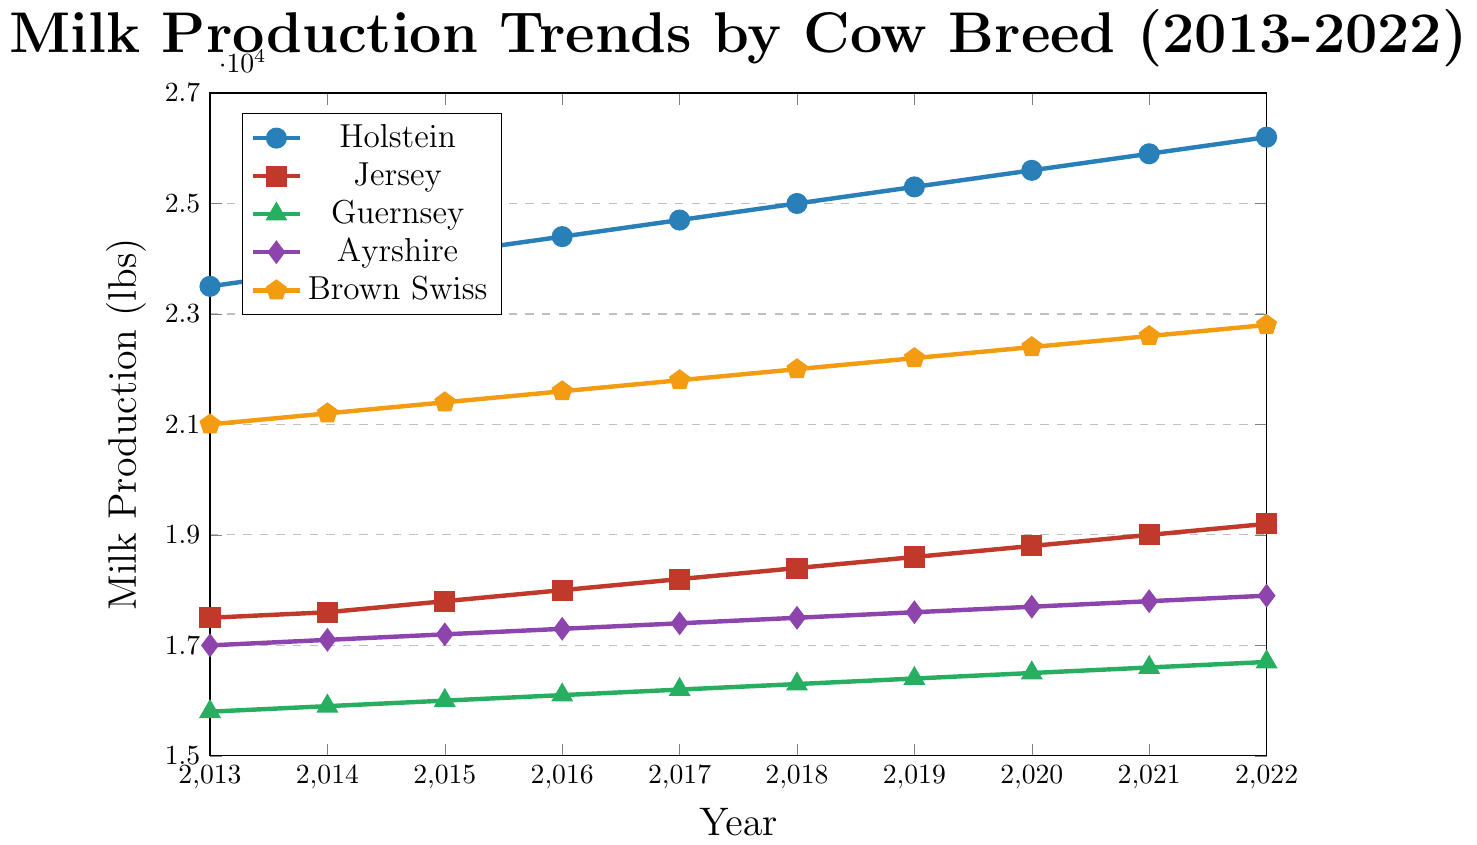What's the breed with the highest milk production in 2022? The graph shows that Holstein cows have the highest milk production in 2022 with approximately 26,200 lbs. Holstein's line is the highest in the chart for 2022.
Answer: Holstein Which breed shows the smallest increase in milk production from 2013 to 2022? By comparing the starting and ending points of each line, Guernsey cows increased from 15,800 lbs in 2013 to 16,700 lbs in 2022, which is the smallest increment of 900 lbs over the period.
Answer: Guernsey What is the total milk production of Jersey cows over the period 2013-2022? Sum up the milk production values for Jersey cows for each year: 17,500 + 17,600 + 17,800 + 18,000 + 18,200 + 18,400 + 18,600 + 18,800 + 19,000 + 19,200. This equals 182,100 lbs.
Answer: 182,100 lbs Which breed had a higher milk production in 2020, Brown Swiss or Ayrshire? From the graph, in 2020 Brown Swiss produced about 22,400 lbs, while Ayrshire produced roughly 17,700 lbs. Brown Swiss produced more.
Answer: Brown Swiss By how much did the milk production of Holstein cows increase every year on average from 2013 to 2022? Calculate the annual increase for Holstein cows: (26,200 - 23,500) / (2022 - 2013) = 2,700 / 9 = 300 lbs per year.
Answer: 300 lbs per year In which year did Guernsey cows' milk production equal Ayrshire cows' milk production? Guernsey and Ayrshire lines never intersect in the graph, meaning their milk production values were never equal between 2013 and 2022.
Answer: Never What is the most significant difference in milk production between any two breeds in 2019? In 2019, Holstein and Guernsey had the most significant difference: 25,300 lbs (Holstein) - 16,400 lbs (Guernsey) = 8,900 lbs.
Answer: 8,900 lbs Which breed had the steadiest increase in milk production over the period? All lines appear to increase steadily, but Holstein shows a constant linear increase without significant deviation. Calculating manually shows Holstein's milk production increased perfectly linearly.
Answer: Holstein What is the average milk production of Ayrshire cows over the period 2013-2022? The milk production values for Ayrshire cows are: 17,000, 17,100, 17,200, 17,300, 17,400, 17,500, 17,600, 17,700, 17,800, and 17,900. The average is (17,000 + 17,100 + 17,200 + 17,300 + 17,400 + 17,500 + 17,600 + 17,700 + 17,800 + 17,900) / 10 = 17,450 lbs.
Answer: 17,450 lbs 